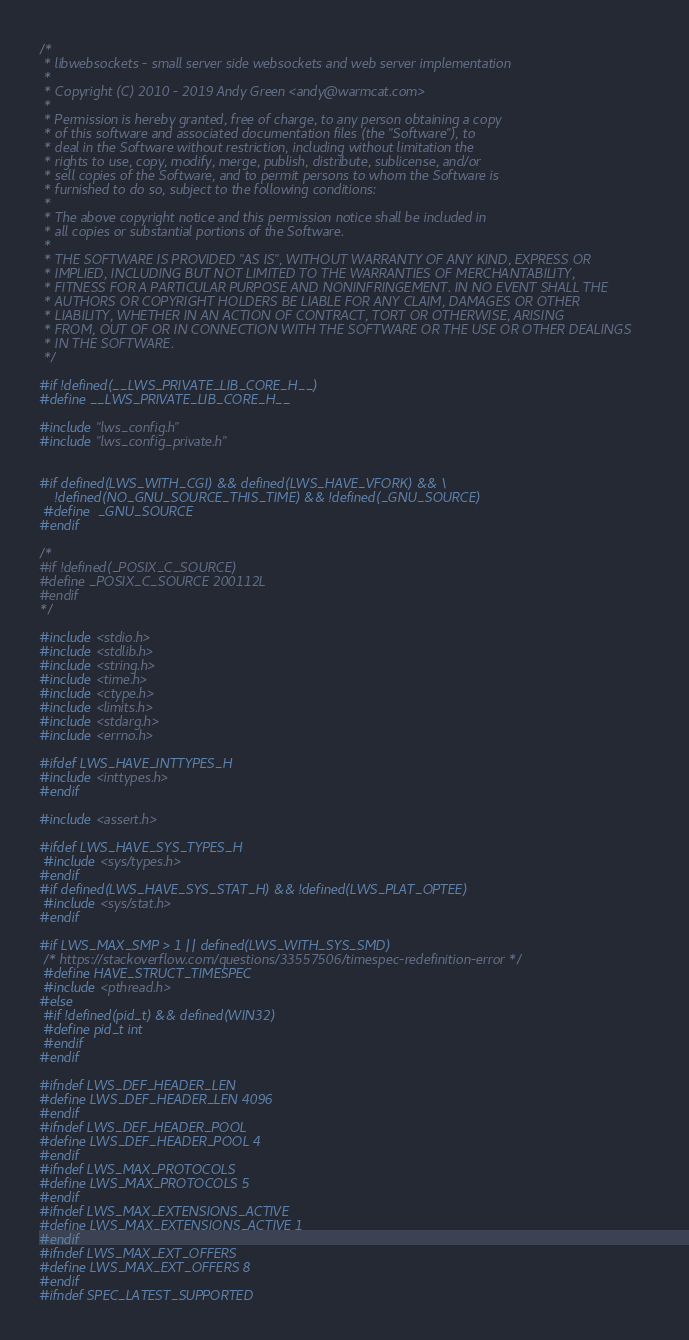<code> <loc_0><loc_0><loc_500><loc_500><_C_>/*
 * libwebsockets - small server side websockets and web server implementation
 *
 * Copyright (C) 2010 - 2019 Andy Green <andy@warmcat.com>
 *
 * Permission is hereby granted, free of charge, to any person obtaining a copy
 * of this software and associated documentation files (the "Software"), to
 * deal in the Software without restriction, including without limitation the
 * rights to use, copy, modify, merge, publish, distribute, sublicense, and/or
 * sell copies of the Software, and to permit persons to whom the Software is
 * furnished to do so, subject to the following conditions:
 *
 * The above copyright notice and this permission notice shall be included in
 * all copies or substantial portions of the Software.
 *
 * THE SOFTWARE IS PROVIDED "AS IS", WITHOUT WARRANTY OF ANY KIND, EXPRESS OR
 * IMPLIED, INCLUDING BUT NOT LIMITED TO THE WARRANTIES OF MERCHANTABILITY,
 * FITNESS FOR A PARTICULAR PURPOSE AND NONINFRINGEMENT. IN NO EVENT SHALL THE
 * AUTHORS OR COPYRIGHT HOLDERS BE LIABLE FOR ANY CLAIM, DAMAGES OR OTHER
 * LIABILITY, WHETHER IN AN ACTION OF CONTRACT, TORT OR OTHERWISE, ARISING
 * FROM, OUT OF OR IN CONNECTION WITH THE SOFTWARE OR THE USE OR OTHER DEALINGS
 * IN THE SOFTWARE.
 */

#if !defined(__LWS_PRIVATE_LIB_CORE_H__)
#define __LWS_PRIVATE_LIB_CORE_H__

#include "lws_config.h"
#include "lws_config_private.h"


#if defined(LWS_WITH_CGI) && defined(LWS_HAVE_VFORK) && \
    !defined(NO_GNU_SOURCE_THIS_TIME) && !defined(_GNU_SOURCE)
 #define  _GNU_SOURCE
#endif

/*
#if !defined(_POSIX_C_SOURCE)
#define _POSIX_C_SOURCE 200112L
#endif
*/

#include <stdio.h>
#include <stdlib.h>
#include <string.h>
#include <time.h>
#include <ctype.h>
#include <limits.h>
#include <stdarg.h>
#include <errno.h>

#ifdef LWS_HAVE_INTTYPES_H
#include <inttypes.h>
#endif

#include <assert.h>

#ifdef LWS_HAVE_SYS_TYPES_H
 #include <sys/types.h>
#endif
#if defined(LWS_HAVE_SYS_STAT_H) && !defined(LWS_PLAT_OPTEE)
 #include <sys/stat.h>
#endif

#if LWS_MAX_SMP > 1 || defined(LWS_WITH_SYS_SMD)
 /* https://stackoverflow.com/questions/33557506/timespec-redefinition-error */
 #define HAVE_STRUCT_TIMESPEC
 #include <pthread.h>
#else
 #if !defined(pid_t) && defined(WIN32)
 #define pid_t int
 #endif
#endif

#ifndef LWS_DEF_HEADER_LEN
#define LWS_DEF_HEADER_LEN 4096
#endif
#ifndef LWS_DEF_HEADER_POOL
#define LWS_DEF_HEADER_POOL 4
#endif
#ifndef LWS_MAX_PROTOCOLS
#define LWS_MAX_PROTOCOLS 5
#endif
#ifndef LWS_MAX_EXTENSIONS_ACTIVE
#define LWS_MAX_EXTENSIONS_ACTIVE 1
#endif
#ifndef LWS_MAX_EXT_OFFERS
#define LWS_MAX_EXT_OFFERS 8
#endif
#ifndef SPEC_LATEST_SUPPORTED</code> 